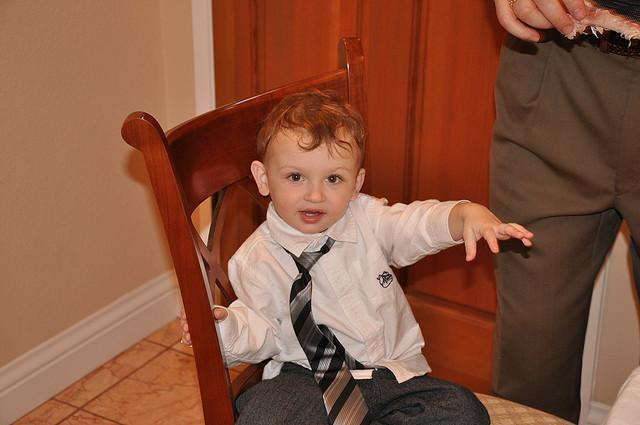What piece of clothing does the boy have on that are meant for adults? Please explain your reasoning. tie. A young child wears a tie. adults generally wear ties more often than children. 